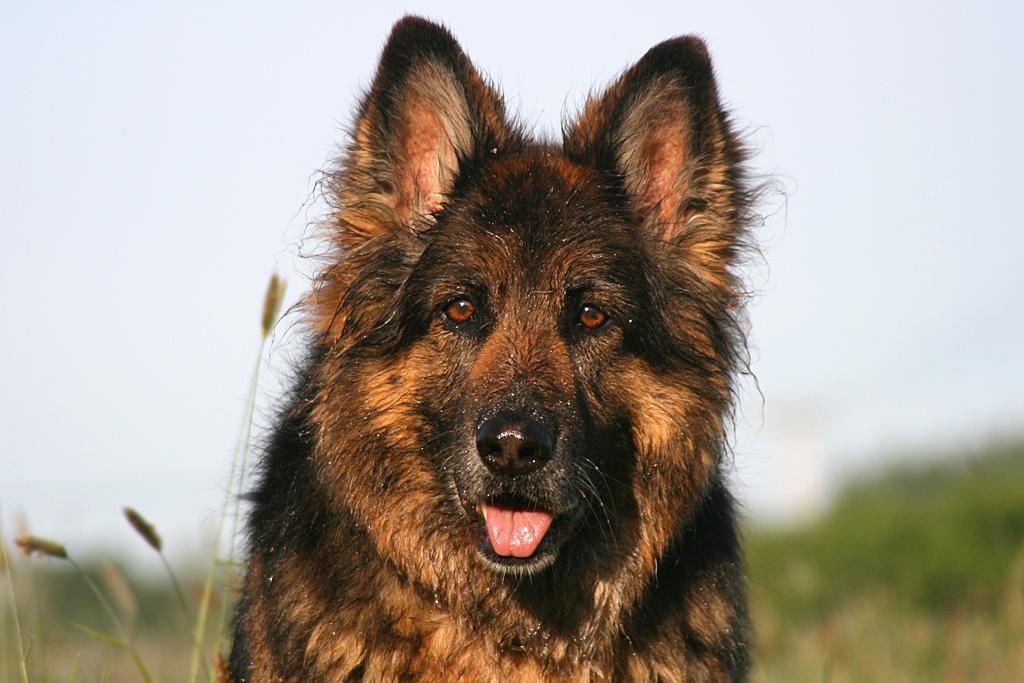In one or two sentences, can you explain what this image depicts? This image consists of a dog in the middle. It is in brown color. There is the grass at the bottom. 